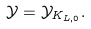Convert formula to latex. <formula><loc_0><loc_0><loc_500><loc_500>\mathcal { Y } = \mathcal { Y } _ { K _ { L , 0 } } .</formula> 